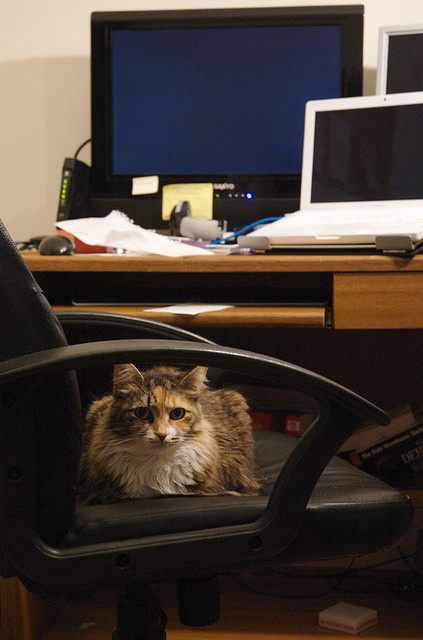Describe the objects in this image and their specific colors. I can see chair in tan, black, maroon, and gray tones, tv in tan, navy, black, and beige tones, cat in tan, maroon, black, and gray tones, laptop in tan, black, white, and darkgray tones, and keyboard in tan, black, maroon, and brown tones in this image. 